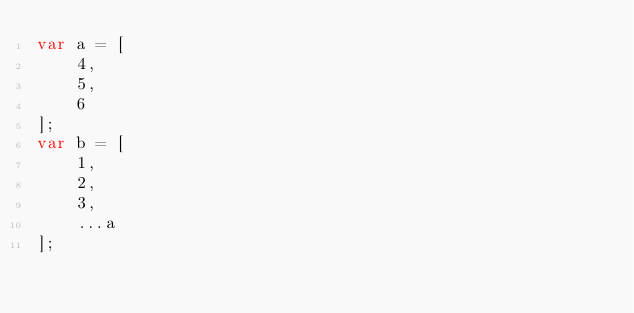<code> <loc_0><loc_0><loc_500><loc_500><_JavaScript_>var a = [
    4,
    5,
    6
];
var b = [
    1,
    2,
    3,
    ...a
];
</code> 